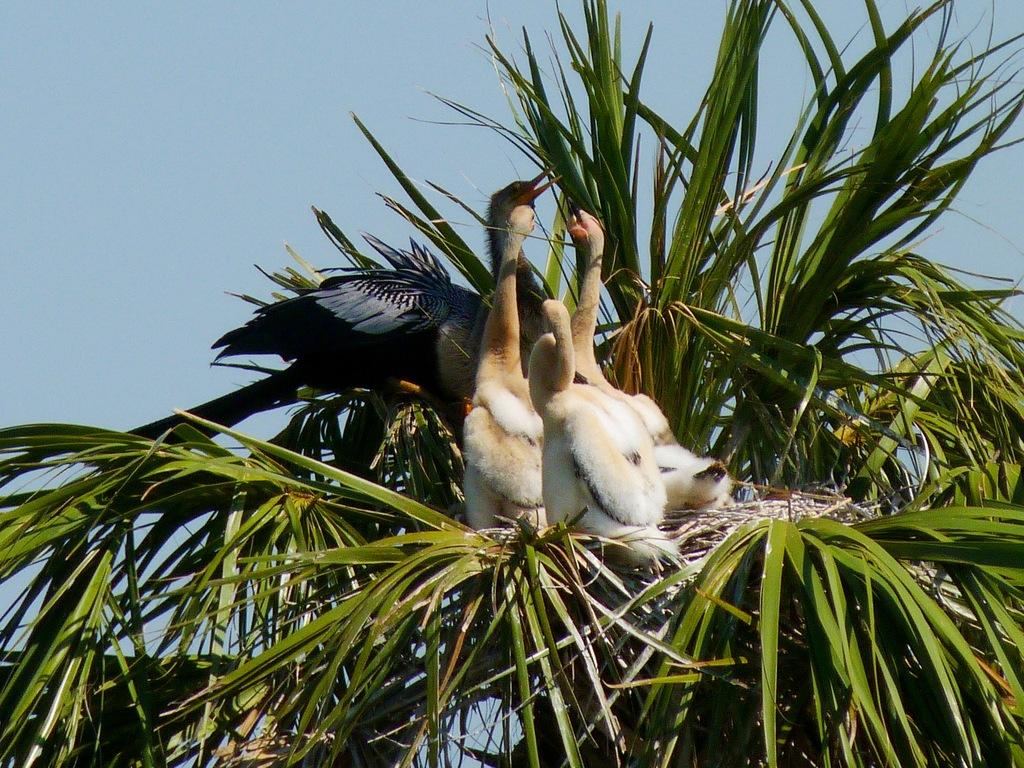What type of animals can be seen in the image? Birds can be seen in the image. What is the primary element in which the birds are situated? The birds are situated in a tree. What part of the natural environment is visible in the image? The sky is visible in the background of the image. What type of trains can be seen passing through the waves in the image? There are no trains or waves present in the image; it features birds in a tree and the sky in the background. 